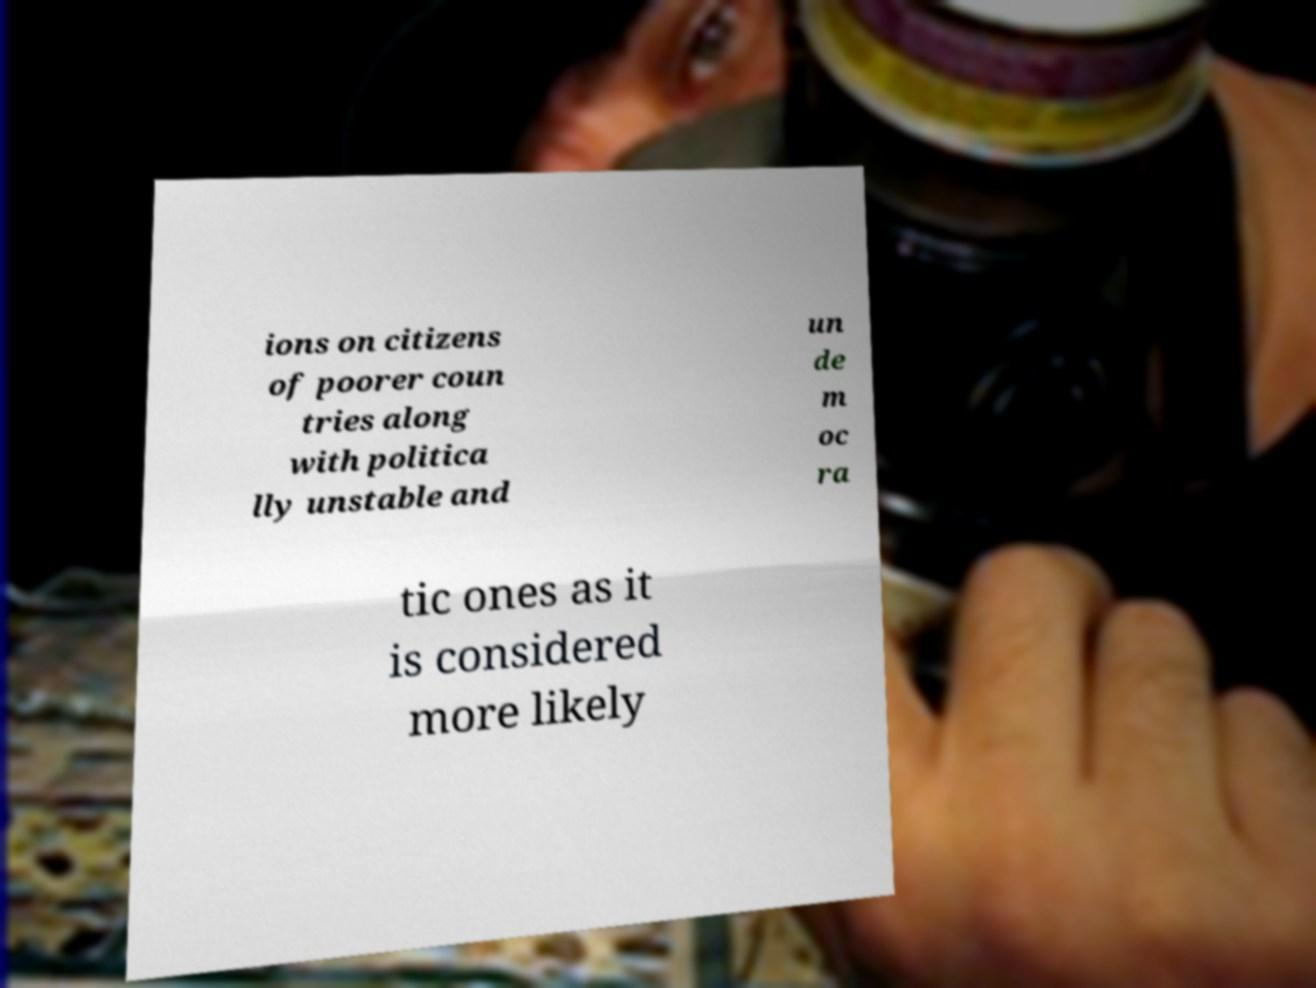Please identify and transcribe the text found in this image. ions on citizens of poorer coun tries along with politica lly unstable and un de m oc ra tic ones as it is considered more likely 